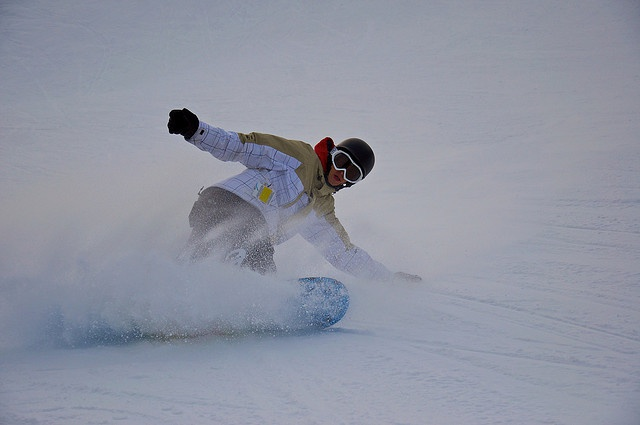Describe the objects in this image and their specific colors. I can see people in gray and black tones and snowboard in gray tones in this image. 